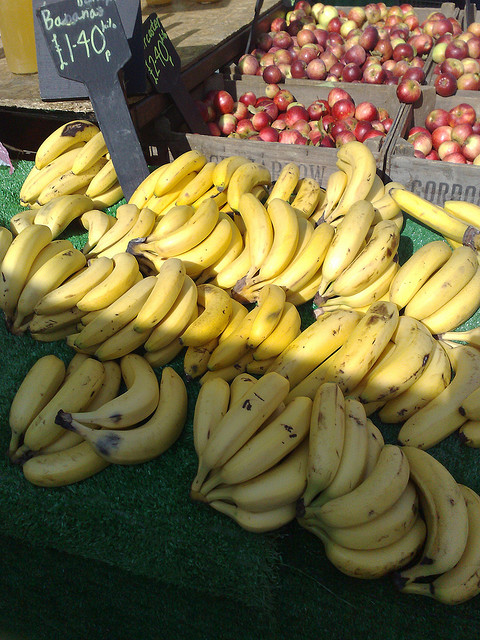What kind of fruits are visible in the image? In the foreground, the main focus is on the bunch of bananas, while in the background there appears to be a stand with red fruits that might be apples. 